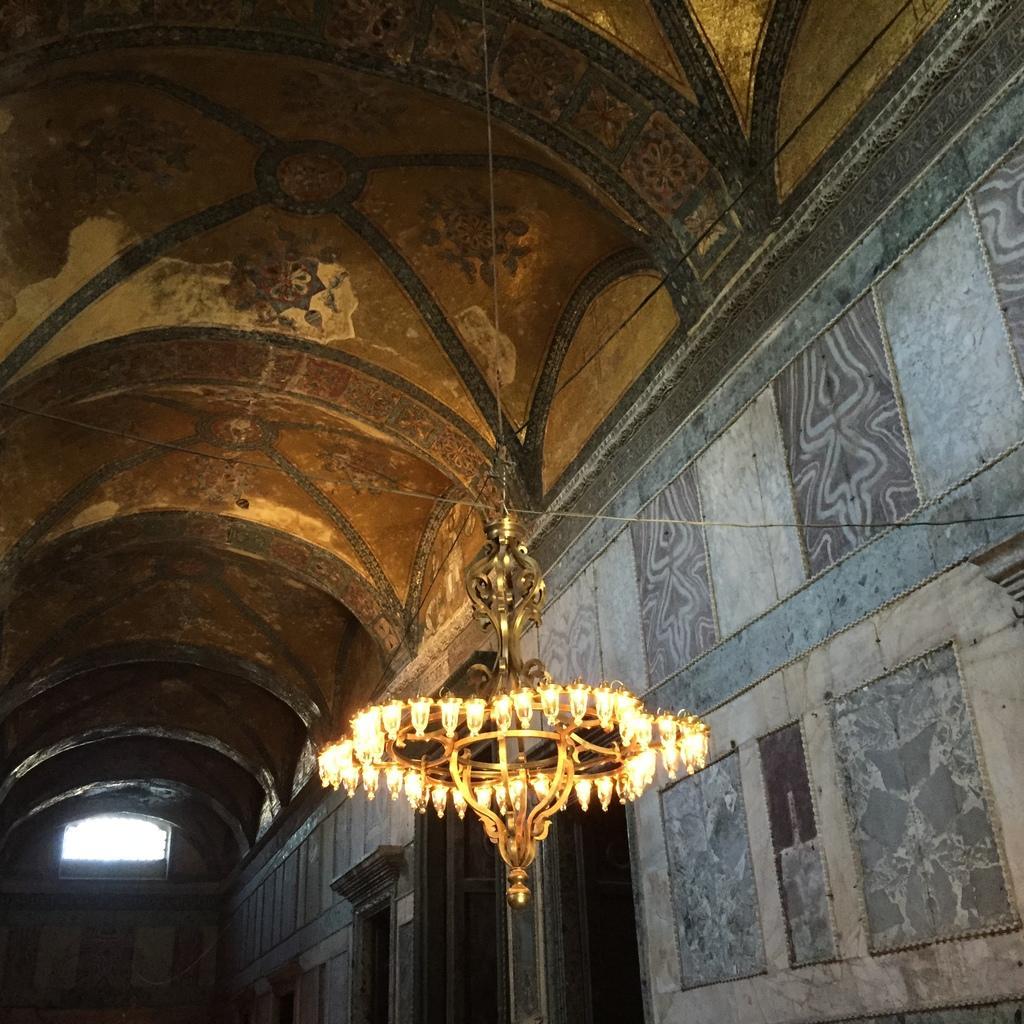How would you summarize this image in a sentence or two? There is a chandelier in the foreground area of the image, there are doors at the bottom side and roof at the top side. 